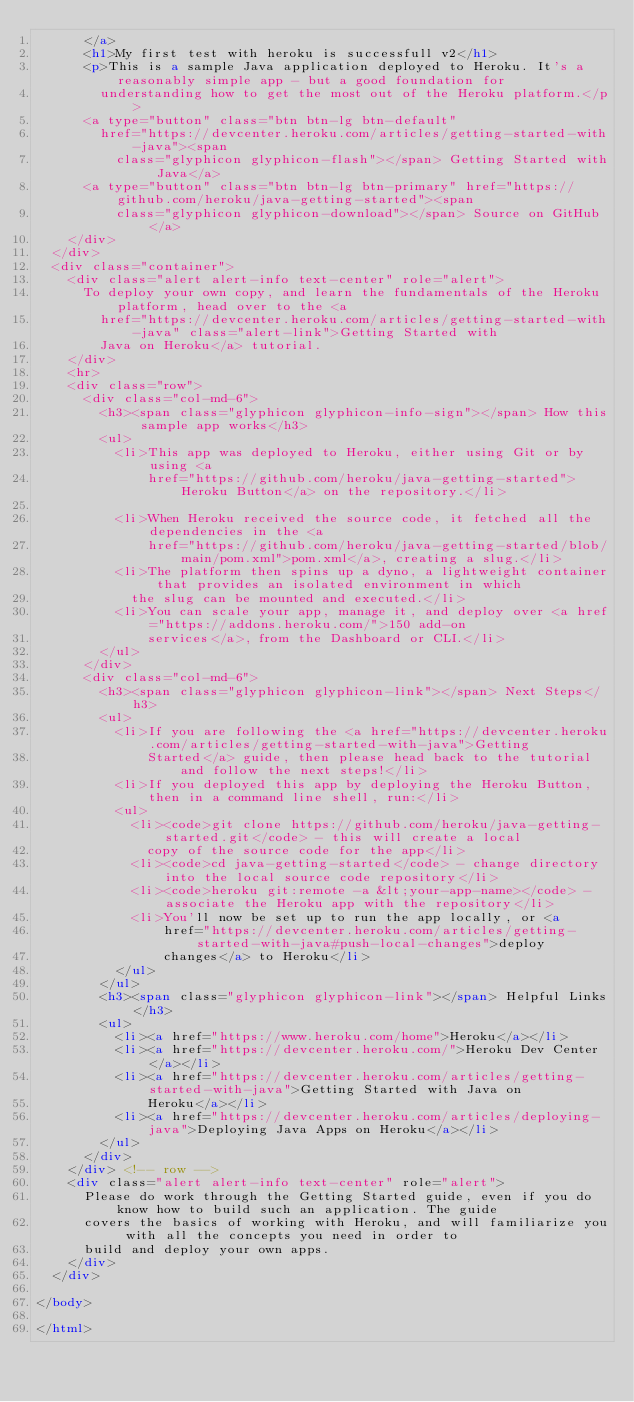Convert code to text. <code><loc_0><loc_0><loc_500><loc_500><_HTML_>      </a>
      <h1>My first test with heroku is successfull v2</h1>
      <p>This is a sample Java application deployed to Heroku. It's a reasonably simple app - but a good foundation for
        understanding how to get the most out of the Heroku platform.</p>
      <a type="button" class="btn btn-lg btn-default"
        href="https://devcenter.heroku.com/articles/getting-started-with-java"><span
          class="glyphicon glyphicon-flash"></span> Getting Started with Java</a>
      <a type="button" class="btn btn-lg btn-primary" href="https://github.com/heroku/java-getting-started"><span
          class="glyphicon glyphicon-download"></span> Source on GitHub</a>
    </div>
  </div>
  <div class="container">
    <div class="alert alert-info text-center" role="alert">
      To deploy your own copy, and learn the fundamentals of the Heroku platform, head over to the <a
        href="https://devcenter.heroku.com/articles/getting-started-with-java" class="alert-link">Getting Started with
        Java on Heroku</a> tutorial.
    </div>
    <hr>
    <div class="row">
      <div class="col-md-6">
        <h3><span class="glyphicon glyphicon-info-sign"></span> How this sample app works</h3>
        <ul>
          <li>This app was deployed to Heroku, either using Git or by using <a
              href="https://github.com/heroku/java-getting-started">Heroku Button</a> on the repository.</li>

          <li>When Heroku received the source code, it fetched all the dependencies in the <a
              href="https://github.com/heroku/java-getting-started/blob/main/pom.xml">pom.xml</a>, creating a slug.</li>
          <li>The platform then spins up a dyno, a lightweight container that provides an isolated environment in which
            the slug can be mounted and executed.</li>
          <li>You can scale your app, manage it, and deploy over <a href="https://addons.heroku.com/">150 add-on
              services</a>, from the Dashboard or CLI.</li>
        </ul>
      </div>
      <div class="col-md-6">
        <h3><span class="glyphicon glyphicon-link"></span> Next Steps</h3>
        <ul>
          <li>If you are following the <a href="https://devcenter.heroku.com/articles/getting-started-with-java">Getting
              Started</a> guide, then please head back to the tutorial and follow the next steps!</li>
          <li>If you deployed this app by deploying the Heroku Button, then in a command line shell, run:</li>
          <ul>
            <li><code>git clone https://github.com/heroku/java-getting-started.git</code> - this will create a local
              copy of the source code for the app</li>
            <li><code>cd java-getting-started</code> - change directory into the local source code repository</li>
            <li><code>heroku git:remote -a &lt;your-app-name></code> - associate the Heroku app with the repository</li>
            <li>You'll now be set up to run the app locally, or <a
                href="https://devcenter.heroku.com/articles/getting-started-with-java#push-local-changes">deploy
                changes</a> to Heroku</li>
          </ul>
        </ul>
        <h3><span class="glyphicon glyphicon-link"></span> Helpful Links</h3>
        <ul>
          <li><a href="https://www.heroku.com/home">Heroku</a></li>
          <li><a href="https://devcenter.heroku.com/">Heroku Dev Center</a></li>
          <li><a href="https://devcenter.heroku.com/articles/getting-started-with-java">Getting Started with Java on
              Heroku</a></li>
          <li><a href="https://devcenter.heroku.com/articles/deploying-java">Deploying Java Apps on Heroku</a></li>
        </ul>
      </div>
    </div> <!-- row -->
    <div class="alert alert-info text-center" role="alert">
      Please do work through the Getting Started guide, even if you do know how to build such an application. The guide
      covers the basics of working with Heroku, and will familiarize you with all the concepts you need in order to
      build and deploy your own apps.
    </div>
  </div>

</body>

</html>
</code> 